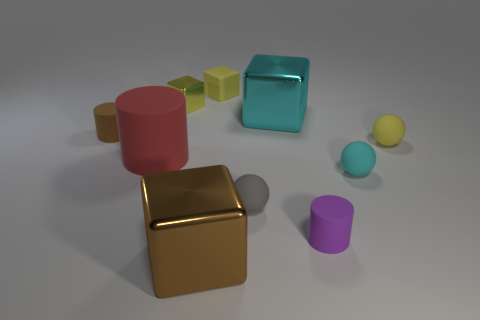Subtract all brown matte cylinders. How many cylinders are left? 2 Subtract all cyan cylinders. How many yellow cubes are left? 2 Subtract all yellow cubes. How many cubes are left? 2 Subtract all cylinders. How many objects are left? 7 Subtract 1 yellow spheres. How many objects are left? 9 Subtract 3 balls. How many balls are left? 0 Subtract all yellow cylinders. Subtract all red balls. How many cylinders are left? 3 Subtract all big metallic blocks. Subtract all tiny cyan matte objects. How many objects are left? 7 Add 4 tiny purple rubber things. How many tiny purple rubber things are left? 5 Add 3 tiny brown balls. How many tiny brown balls exist? 3 